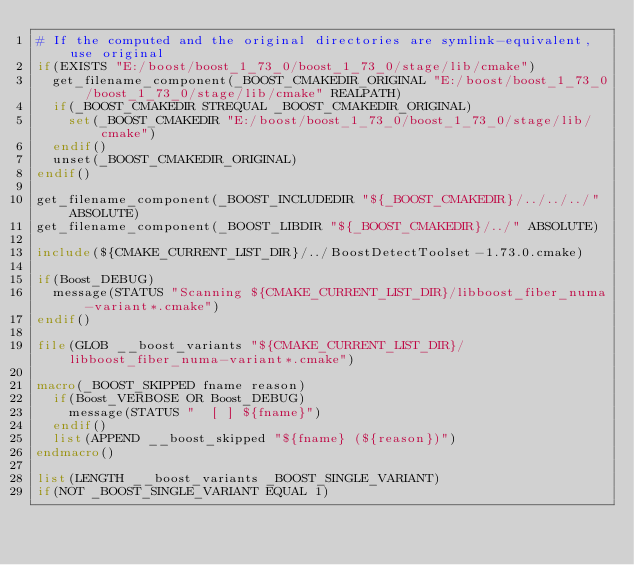Convert code to text. <code><loc_0><loc_0><loc_500><loc_500><_CMake_># If the computed and the original directories are symlink-equivalent, use original
if(EXISTS "E:/boost/boost_1_73_0/boost_1_73_0/stage/lib/cmake")
  get_filename_component(_BOOST_CMAKEDIR_ORIGINAL "E:/boost/boost_1_73_0/boost_1_73_0/stage/lib/cmake" REALPATH)
  if(_BOOST_CMAKEDIR STREQUAL _BOOST_CMAKEDIR_ORIGINAL)
    set(_BOOST_CMAKEDIR "E:/boost/boost_1_73_0/boost_1_73_0/stage/lib/cmake")
  endif()
  unset(_BOOST_CMAKEDIR_ORIGINAL)
endif()

get_filename_component(_BOOST_INCLUDEDIR "${_BOOST_CMAKEDIR}/../../../" ABSOLUTE)
get_filename_component(_BOOST_LIBDIR "${_BOOST_CMAKEDIR}/../" ABSOLUTE)

include(${CMAKE_CURRENT_LIST_DIR}/../BoostDetectToolset-1.73.0.cmake)

if(Boost_DEBUG)
  message(STATUS "Scanning ${CMAKE_CURRENT_LIST_DIR}/libboost_fiber_numa-variant*.cmake")
endif()

file(GLOB __boost_variants "${CMAKE_CURRENT_LIST_DIR}/libboost_fiber_numa-variant*.cmake")

macro(_BOOST_SKIPPED fname reason)
  if(Boost_VERBOSE OR Boost_DEBUG)
    message(STATUS "  [ ] ${fname}")
  endif()
  list(APPEND __boost_skipped "${fname} (${reason})")
endmacro()

list(LENGTH __boost_variants _BOOST_SINGLE_VARIANT)
if(NOT _BOOST_SINGLE_VARIANT EQUAL 1)</code> 